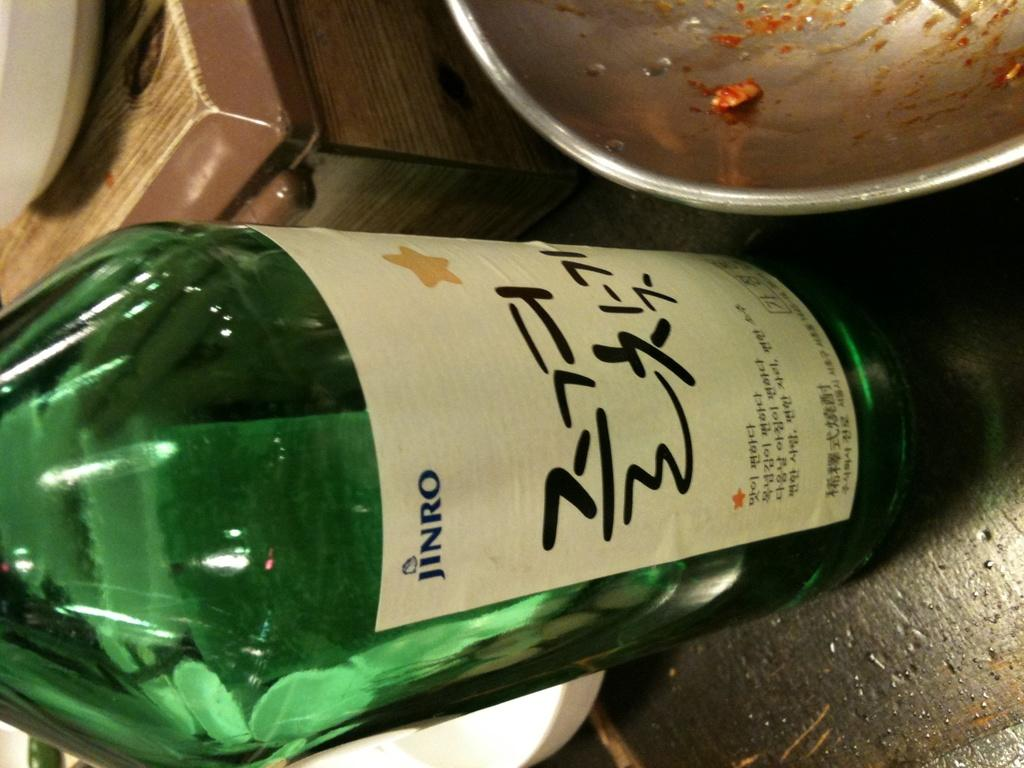<image>
Share a concise interpretation of the image provided. A bottle of Jinro next to a metal bowl with food residue. 